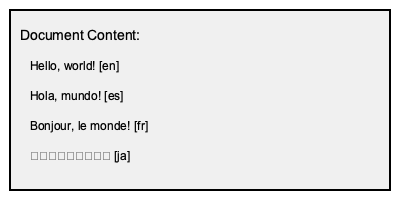In the multilingual document shown above, what do the two-letter codes in square brackets represent, and why are they important for Microsoft Translator? To answer this question, let's break it down step-by-step:

1. Observe the document content:
   - Each line contains text in a different language.
   - After each text, there's a two-letter code in square brackets.

2. Identify the codes:
   - [en] for "Hello, world!"
   - [es] for "Hola, mundo!"
   - [fr] for "Bonjour, le monde!"
   - [ja] for "こんにちは、世界！"

3. Recognize the pattern:
   - These codes correspond to ISO 639-1 language codes.
   - [en] represents English, [es] Spanish, [fr] French, and [ja] Japanese.

4. Understand their importance for Microsoft Translator:
   - Language codes act as "flags" to identify the language of each segment.
   - They allow Microsoft Translator to:
     a) Correctly identify the source language for each segment.
     b) Apply appropriate translation models for each language pair.
     c) Maintain the document's multilingual structure during translation.
     d) Ensure accurate language-specific processing (e.g., character encoding for Japanese).

5. Conclusion:
   These codes are crucial for maintaining linguistic accuracy and structure in multilingual document translation.
Answer: ISO 639-1 language codes, crucial for identifying source languages and applying correct translation models. 